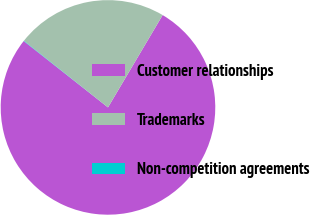<chart> <loc_0><loc_0><loc_500><loc_500><pie_chart><fcel>Customer relationships<fcel>Trademarks<fcel>Non-competition agreements<nl><fcel>77.11%<fcel>22.84%<fcel>0.05%<nl></chart> 